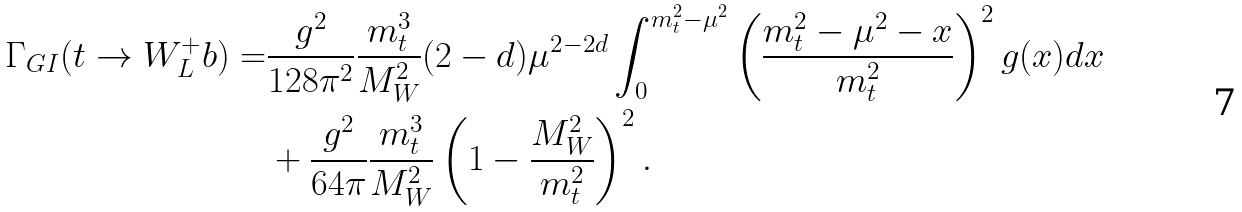<formula> <loc_0><loc_0><loc_500><loc_500>\Gamma _ { G I } ( t \rightarrow W _ { L } ^ { + } b ) = & \frac { g ^ { 2 } } { 1 2 8 \pi ^ { 2 } } \frac { m _ { t } ^ { 3 } } { M _ { W } ^ { 2 } } ( 2 - d ) \mu ^ { 2 - 2 d } \int _ { 0 } ^ { m _ { t } ^ { 2 } - \mu ^ { 2 } } \left ( \frac { m _ { t } ^ { 2 } - \mu ^ { 2 } - x } { m _ { t } ^ { 2 } } \right ) ^ { 2 } g ( x ) d x \\ & + \frac { g ^ { 2 } } { 6 4 \pi } \frac { m _ { t } ^ { 3 } } { M _ { W } ^ { 2 } } \left ( 1 - \frac { M _ { W } ^ { 2 } } { m _ { t } ^ { 2 } } \right ) ^ { 2 } .</formula> 